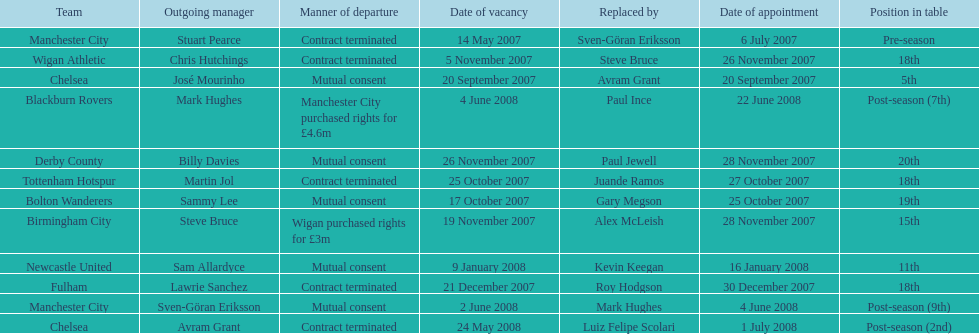Who was manager of manchester city after stuart pearce left in 2007? Sven-Göran Eriksson. 